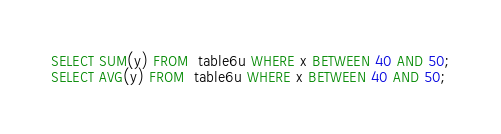Convert code to text. <code><loc_0><loc_0><loc_500><loc_500><_SQL_>SELECT SUM(y) FROM  table6u WHERE x BETWEEN 40 AND 50;
SELECT AVG(y) FROM  table6u WHERE x BETWEEN 40 AND 50;</code> 